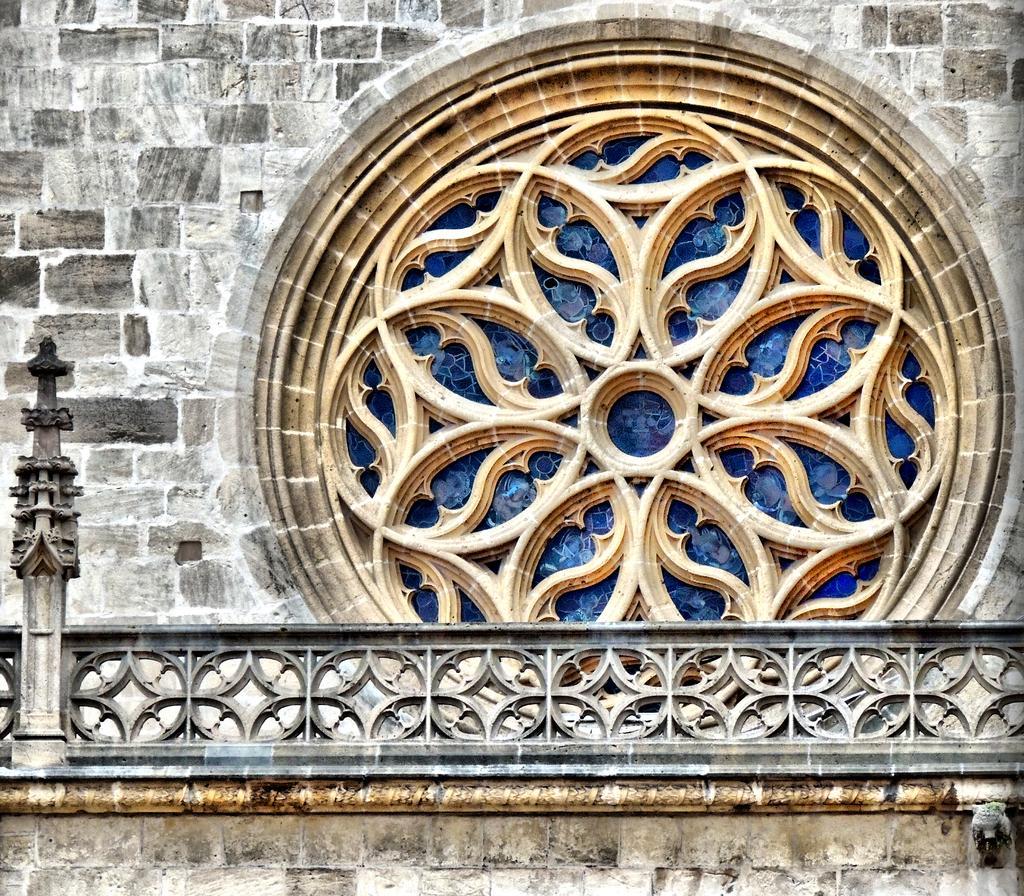Describe this image in one or two sentences. In this image we can see a wall, there is a design with glass, also we can see grills. 